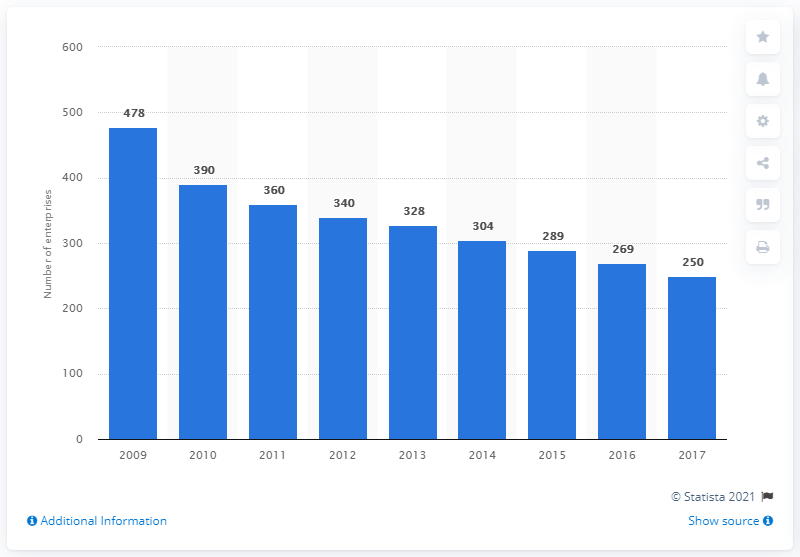Point out several critical features in this image. In 2017, there were 250 enterprises in the Czech Republic that produced computers and related equipment. 